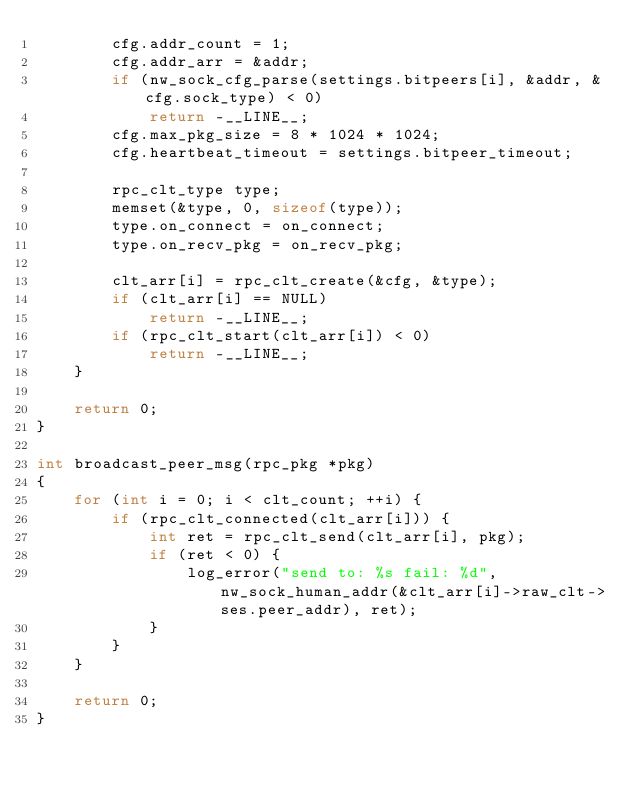<code> <loc_0><loc_0><loc_500><loc_500><_C_>        cfg.addr_count = 1;
        cfg.addr_arr = &addr;
        if (nw_sock_cfg_parse(settings.bitpeers[i], &addr, &cfg.sock_type) < 0)
            return -__LINE__;
        cfg.max_pkg_size = 8 * 1024 * 1024;
        cfg.heartbeat_timeout = settings.bitpeer_timeout;

        rpc_clt_type type;
        memset(&type, 0, sizeof(type));
        type.on_connect = on_connect;
        type.on_recv_pkg = on_recv_pkg;

        clt_arr[i] = rpc_clt_create(&cfg, &type);
        if (clt_arr[i] == NULL)
            return -__LINE__;
        if (rpc_clt_start(clt_arr[i]) < 0)
            return -__LINE__;
    }

    return 0;
}

int broadcast_peer_msg(rpc_pkg *pkg)
{
    for (int i = 0; i < clt_count; ++i) {
        if (rpc_clt_connected(clt_arr[i])) {
            int ret = rpc_clt_send(clt_arr[i], pkg);
            if (ret < 0) {
                log_error("send to: %s fail: %d", nw_sock_human_addr(&clt_arr[i]->raw_clt->ses.peer_addr), ret);
            }
        }
    }

    return 0;
}

</code> 